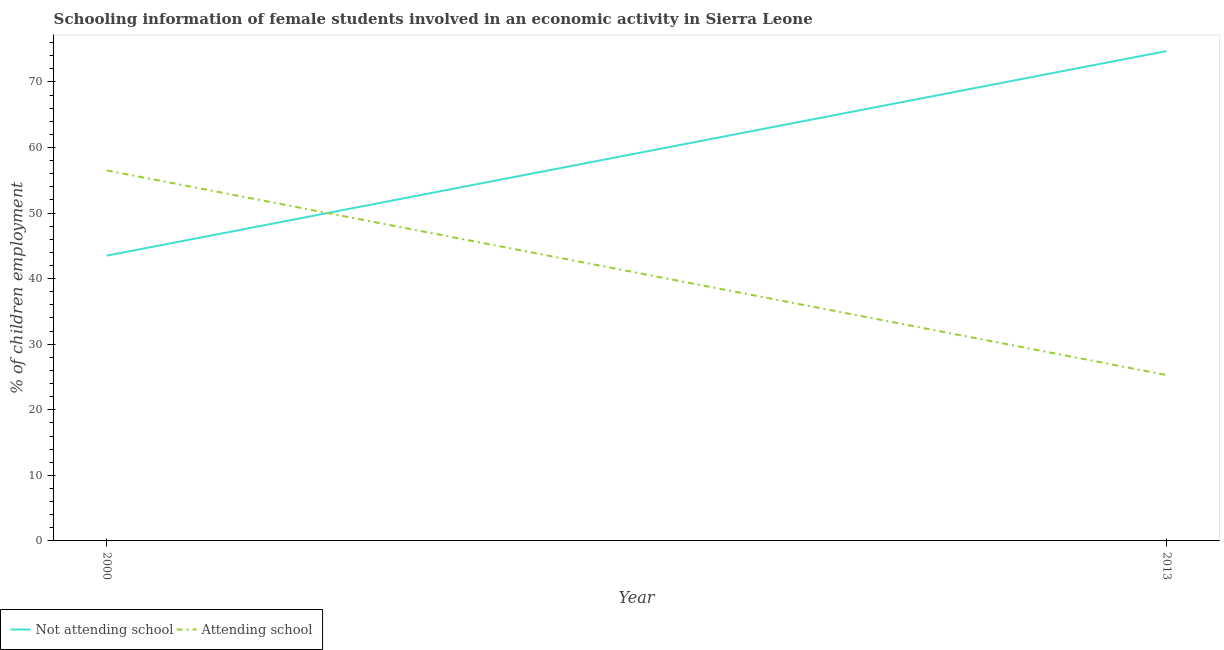How many different coloured lines are there?
Your response must be concise. 2. Does the line corresponding to percentage of employed females who are attending school intersect with the line corresponding to percentage of employed females who are not attending school?
Your answer should be very brief. Yes. What is the percentage of employed females who are attending school in 2013?
Your response must be concise. 25.3. Across all years, what is the maximum percentage of employed females who are not attending school?
Provide a succinct answer. 74.7. Across all years, what is the minimum percentage of employed females who are not attending school?
Your answer should be very brief. 43.5. In which year was the percentage of employed females who are attending school minimum?
Make the answer very short. 2013. What is the total percentage of employed females who are attending school in the graph?
Ensure brevity in your answer.  81.8. What is the difference between the percentage of employed females who are not attending school in 2000 and that in 2013?
Give a very brief answer. -31.2. What is the difference between the percentage of employed females who are attending school in 2013 and the percentage of employed females who are not attending school in 2000?
Offer a very short reply. -18.2. What is the average percentage of employed females who are attending school per year?
Your answer should be very brief. 40.9. In how many years, is the percentage of employed females who are attending school greater than 72 %?
Your response must be concise. 0. What is the ratio of the percentage of employed females who are not attending school in 2000 to that in 2013?
Offer a terse response. 0.58. Is the percentage of employed females who are attending school in 2000 less than that in 2013?
Your response must be concise. No. In how many years, is the percentage of employed females who are not attending school greater than the average percentage of employed females who are not attending school taken over all years?
Provide a short and direct response. 1. Does the percentage of employed females who are attending school monotonically increase over the years?
Provide a succinct answer. No. How many lines are there?
Your answer should be very brief. 2. How many years are there in the graph?
Offer a very short reply. 2. How many legend labels are there?
Offer a terse response. 2. What is the title of the graph?
Offer a terse response. Schooling information of female students involved in an economic activity in Sierra Leone. What is the label or title of the X-axis?
Provide a succinct answer. Year. What is the label or title of the Y-axis?
Make the answer very short. % of children employment. What is the % of children employment in Not attending school in 2000?
Keep it short and to the point. 43.5. What is the % of children employment in Attending school in 2000?
Provide a short and direct response. 56.5. What is the % of children employment of Not attending school in 2013?
Ensure brevity in your answer.  74.7. What is the % of children employment in Attending school in 2013?
Ensure brevity in your answer.  25.3. Across all years, what is the maximum % of children employment in Not attending school?
Give a very brief answer. 74.7. Across all years, what is the maximum % of children employment of Attending school?
Your answer should be very brief. 56.5. Across all years, what is the minimum % of children employment in Not attending school?
Give a very brief answer. 43.5. Across all years, what is the minimum % of children employment of Attending school?
Your answer should be very brief. 25.3. What is the total % of children employment of Not attending school in the graph?
Your response must be concise. 118.2. What is the total % of children employment in Attending school in the graph?
Provide a succinct answer. 81.8. What is the difference between the % of children employment in Not attending school in 2000 and that in 2013?
Your answer should be compact. -31.2. What is the difference between the % of children employment of Attending school in 2000 and that in 2013?
Give a very brief answer. 31.2. What is the difference between the % of children employment of Not attending school in 2000 and the % of children employment of Attending school in 2013?
Provide a succinct answer. 18.2. What is the average % of children employment in Not attending school per year?
Your answer should be very brief. 59.1. What is the average % of children employment in Attending school per year?
Your answer should be compact. 40.9. In the year 2000, what is the difference between the % of children employment of Not attending school and % of children employment of Attending school?
Your response must be concise. -13. In the year 2013, what is the difference between the % of children employment of Not attending school and % of children employment of Attending school?
Provide a short and direct response. 49.4. What is the ratio of the % of children employment in Not attending school in 2000 to that in 2013?
Ensure brevity in your answer.  0.58. What is the ratio of the % of children employment in Attending school in 2000 to that in 2013?
Provide a short and direct response. 2.23. What is the difference between the highest and the second highest % of children employment in Not attending school?
Provide a succinct answer. 31.2. What is the difference between the highest and the second highest % of children employment in Attending school?
Ensure brevity in your answer.  31.2. What is the difference between the highest and the lowest % of children employment in Not attending school?
Your answer should be very brief. 31.2. What is the difference between the highest and the lowest % of children employment of Attending school?
Ensure brevity in your answer.  31.2. 